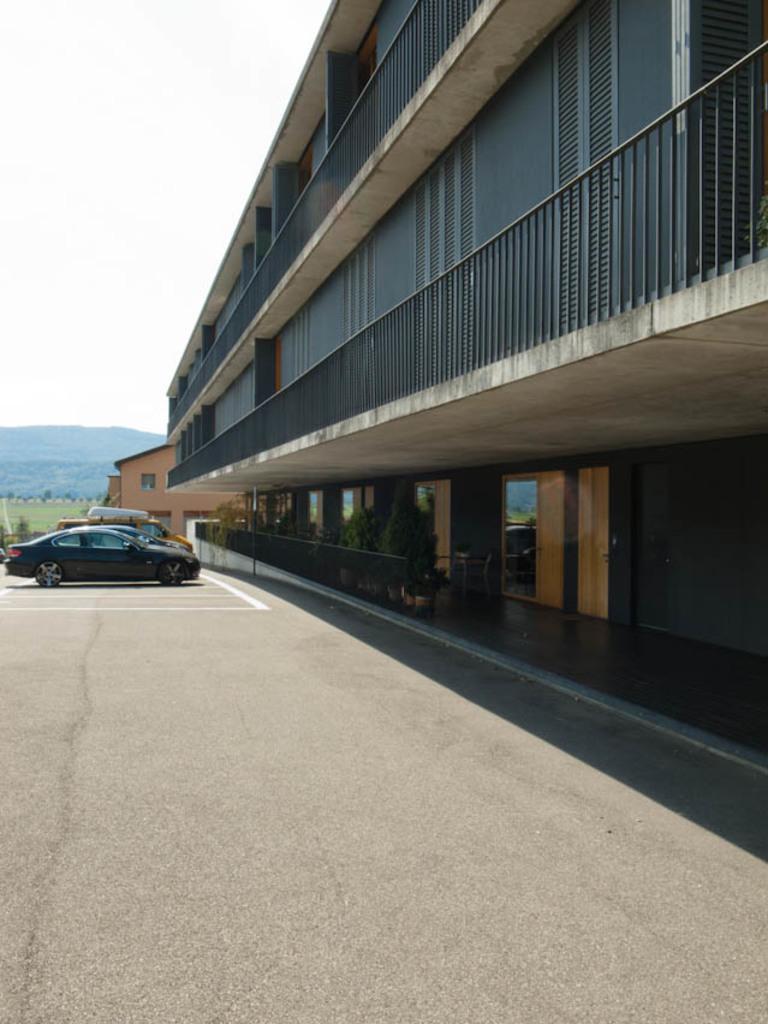Describe this image in one or two sentences. In this image we can see sky, buildings, motor vehicles, road, iron grill, plants, ground and trees. 